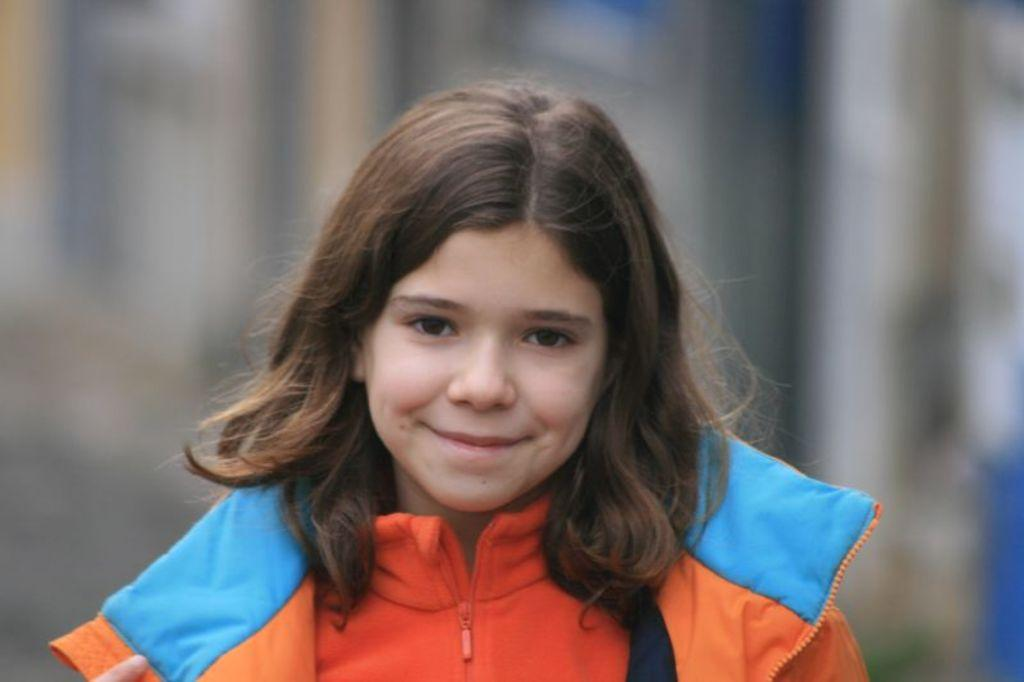Who is the main subject in the image? There is a girl in the image. Where is the girl positioned in the image? The girl is in the center of the image. What is the girl's facial expression? The girl is smiling. What color is the jacket the girl is wearing? The girl is wearing an orange color jacket. What type of pest can be seen crawling on the girl's hands in the image? There are no pests visible in the image, and the girl's hands are not shown. 